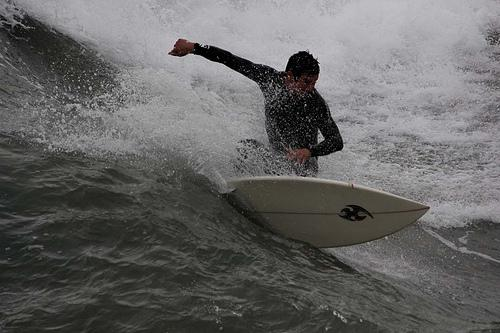Question: how is the surfboard pointing?
Choices:
A. Upside down.
B. To the west.
C. The beach.
D. Right.
Answer with the letter. Answer: D Question: who is in the water?
Choices:
A. Three people from a company picnic.
B. A Dog.
C. A girl with an inner tube.
D. A man.
Answer with the letter. Answer: D Question: where is the man surfing?
Choices:
A. On the internet.
B. On a wave.
C. Ocean.
D. Lake.
Answer with the letter. Answer: C Question: how is the man's right arm?
Choices:
A. In his pockets.
B. To the right.
C. A little shorter than the other arm.
D. Extended.
Answer with the letter. Answer: D Question: what is the man riding?
Choices:
A. An inner tube.
B. Surfboard.
C. A boat.
D. A raft.
Answer with the letter. Answer: B Question: what is the man doing?
Choices:
A. Swimming.
B. Surfing.
C. Getting exercise.
D. Cooling off.
Answer with the letter. Answer: B 